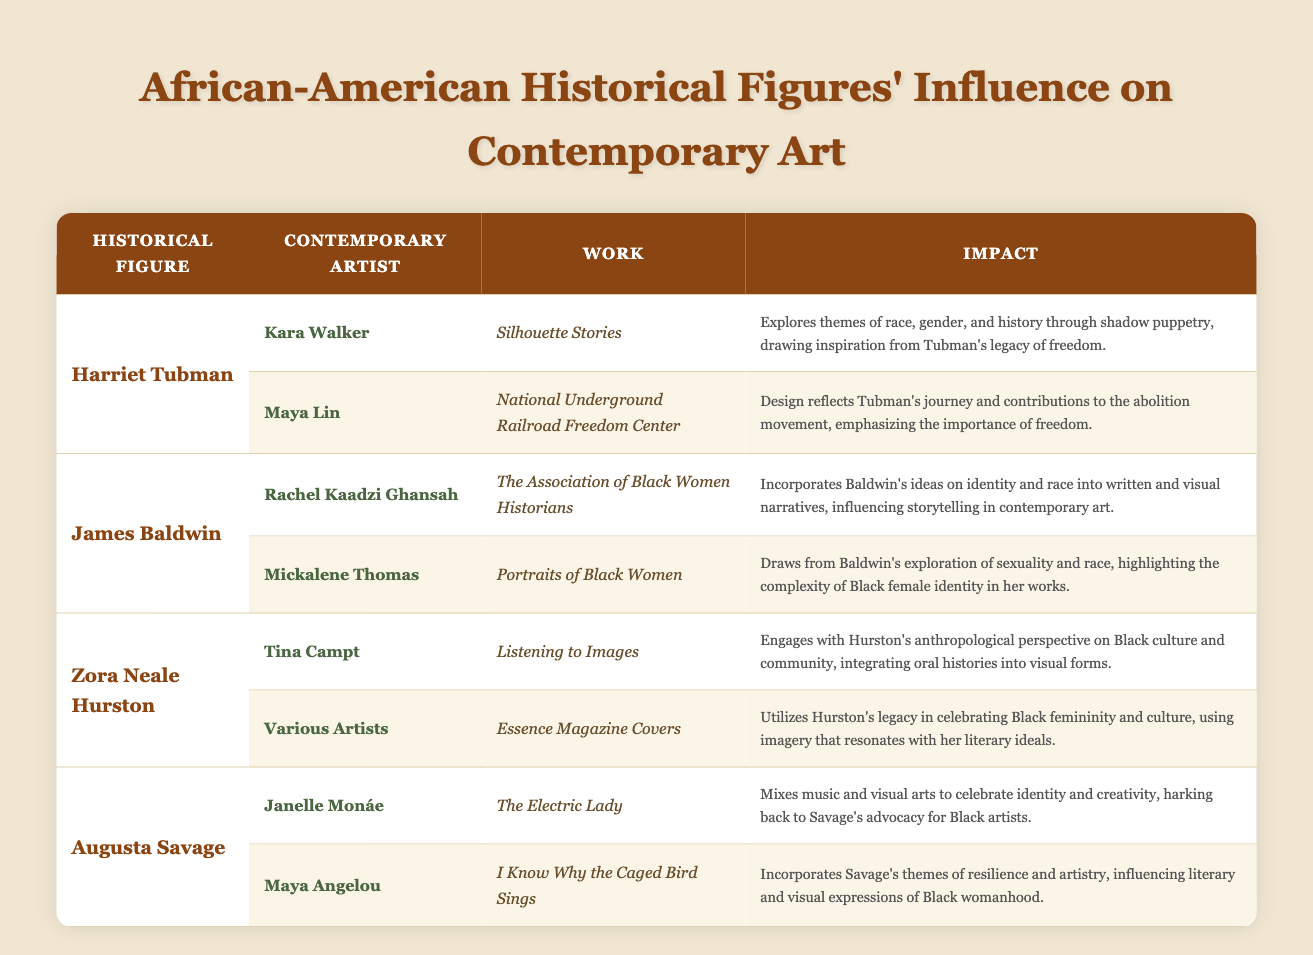What contemporary artist is influenced by Harriet Tubman? The table lists Kara Walker and Maya Lin as contemporary artists influenced by Harriet Tubman.
Answer: Kara Walker and Maya Lin How many contemporary artists are influenced by Zora Neale Hurston? The table shows two contemporary artists influenced by Zora Neale Hurston: Tina Campt and various artists associated with Essence Magazine Covers.
Answer: Two What work did Mickalene Thomas create that draws from James Baldwin's exploration of identity? According to the table, Mickalene Thomas created "Portraits of Black Women" which draws from Baldwin’s exploration of sexuality and race.
Answer: Portraits of Black Women Did Janelle Monáe create a work that celebrates Augusta Savage’s influence? Yes, the table indicates that Janelle Monáe's work "The Electric Lady" celebrates identity and creativity, harking back to Augusta Savage’s advocacy for Black artists.
Answer: Yes Which historical figure has the most contemporary artists listed as influenced by their work? By examining the table, both Harriet Tubman and James Baldwin each have two contemporary artists listed, while Zora Neale Hurston and Augusta Savage also have two, meaning there is a tie among some figures.
Answer: Harriet Tubman and James Baldwin (tie) 